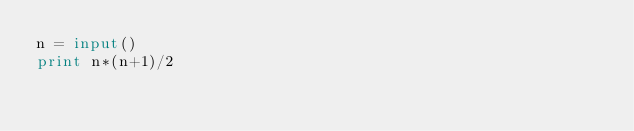Convert code to text. <code><loc_0><loc_0><loc_500><loc_500><_Python_>n = input()
print n*(n+1)/2
</code> 